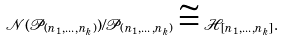Convert formula to latex. <formula><loc_0><loc_0><loc_500><loc_500>\mathcal { N } ( \mathcal { P } _ { ( n _ { 1 } , \dots , n _ { k } ) } ) / \mathcal { P } _ { ( n _ { 1 } , \dots , n _ { k } ) } \cong \mathcal { H } _ { [ n _ { 1 } , \dots , n _ { k } ] } .</formula> 